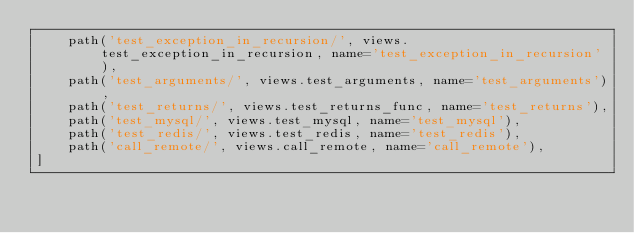Convert code to text. <code><loc_0><loc_0><loc_500><loc_500><_Python_>    path('test_exception_in_recursion/', views.test_exception_in_recursion, name='test_exception_in_recursion'),
    path('test_arguments/', views.test_arguments, name='test_arguments'),
    path('test_returns/', views.test_returns_func, name='test_returns'),
    path('test_mysql/', views.test_mysql, name='test_mysql'),
    path('test_redis/', views.test_redis, name='test_redis'),
    path('call_remote/', views.call_remote, name='call_remote'),
]
</code> 